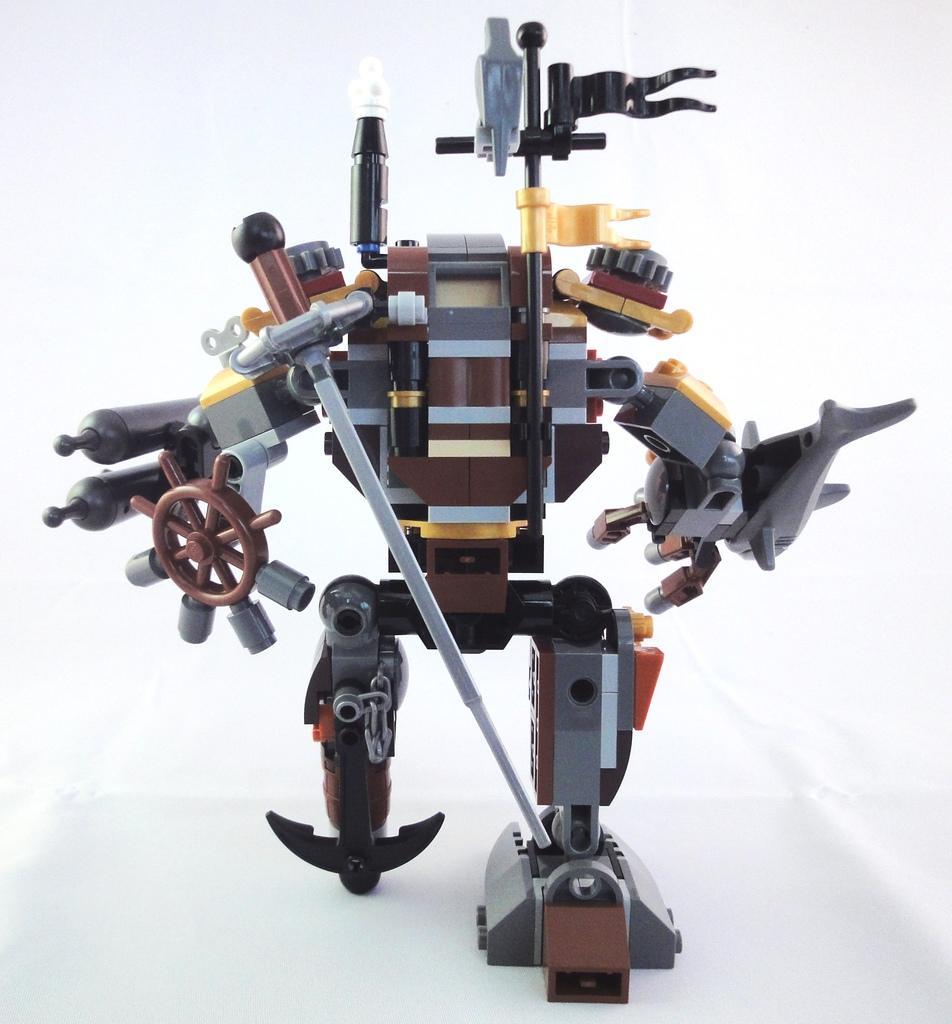In one or two sentences, can you explain what this image depicts? In this picture, we see the robot in brown, black, grey and yellow color. In the background, it is white in color. 